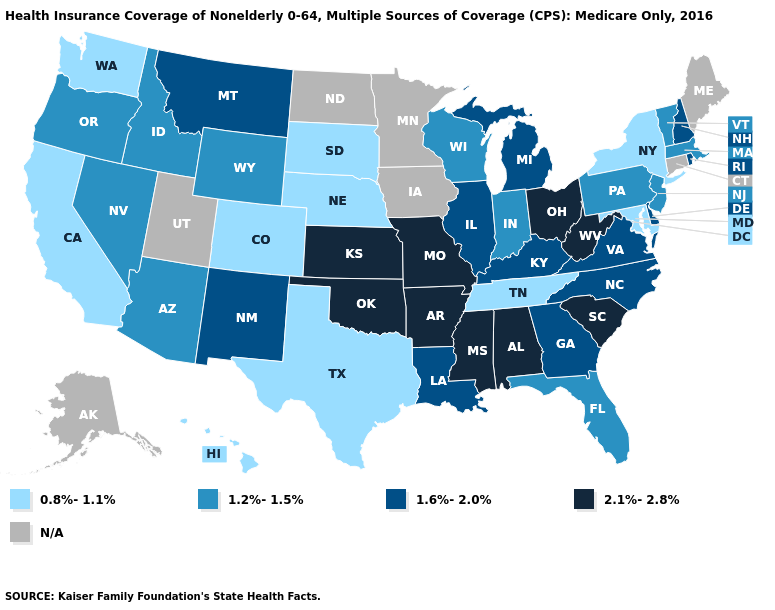What is the value of Delaware?
Keep it brief. 1.6%-2.0%. Among the states that border Arkansas , which have the lowest value?
Concise answer only. Tennessee, Texas. Which states have the highest value in the USA?
Write a very short answer. Alabama, Arkansas, Kansas, Mississippi, Missouri, Ohio, Oklahoma, South Carolina, West Virginia. What is the value of Ohio?
Short answer required. 2.1%-2.8%. Does the map have missing data?
Write a very short answer. Yes. Name the states that have a value in the range 2.1%-2.8%?
Concise answer only. Alabama, Arkansas, Kansas, Mississippi, Missouri, Ohio, Oklahoma, South Carolina, West Virginia. Is the legend a continuous bar?
Concise answer only. No. What is the value of Alaska?
Answer briefly. N/A. Which states have the lowest value in the MidWest?
Answer briefly. Nebraska, South Dakota. What is the lowest value in the MidWest?
Give a very brief answer. 0.8%-1.1%. Which states hav the highest value in the Northeast?
Short answer required. New Hampshire, Rhode Island. Does New York have the lowest value in the Northeast?
Give a very brief answer. Yes. Does the map have missing data?
Write a very short answer. Yes. Name the states that have a value in the range 1.6%-2.0%?
Short answer required. Delaware, Georgia, Illinois, Kentucky, Louisiana, Michigan, Montana, New Hampshire, New Mexico, North Carolina, Rhode Island, Virginia. Does Kansas have the highest value in the MidWest?
Write a very short answer. Yes. 